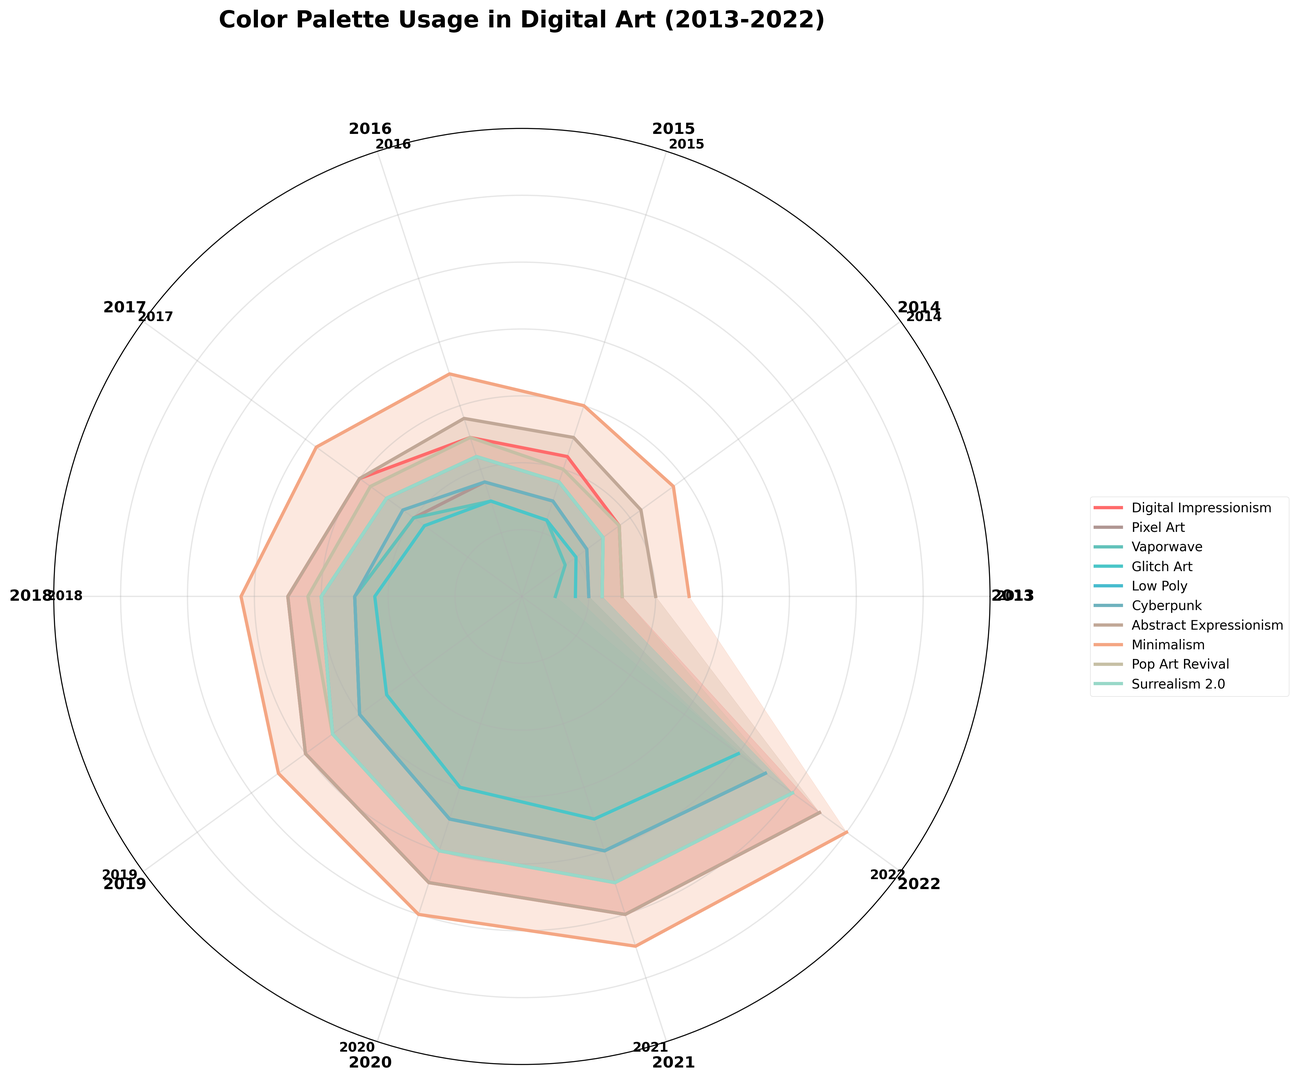Which artistic movement showed the most significant increase in color palette usage between 2018 and 2022? To find the movement with the most significant increase, we look at the difference between 2018 and 2022 for each movement. By observing the plotted values, Minimalism had an increase from 42 to 60, which is 18, the highest increase among the movements.
Answer: Minimalism In which year did Digital Impressionism surpass 40 in color palette usage? We look at the plotted values for Digital Impressionism and identify the year where it first reached or exceeded 40. The values surpass 40 in 2019 with a value of 40.
Answer: 2019 What is the median value of color palette usage for Abstract Expressionism across all years? There are 10 data points for Abstract Expressionism. To find the median, order values (20, 22, 25, 28, 30, 35, 40, 45, 50, 55) and the median would be the average of the 5th and 6th values: (30+35)/2 = 32.5
Answer: 32.5 Which two years showed the steepest slope in color palette usage for Cyberpunk? Observing the plot for Cyberpunk, we identify two years between which the increase is the steepest. The slope from 2017 (22) to 2018 (25) shows a steep increase compared to other years.
Answer: 2017 and 2018 How did the usage of color palettes in Pixel Art change from 2013 to 2020? To determine the change, subtract the usage in 2013 (10) from that in 2020 (35). The change is 35 - 10 = 25.
Answer: Increased by 25 Which artistic movement had the least variation in color palette usage over the decade? By observing the radii (lengths) and fluctuation in the plot, Digital Impressionism, starting at 15 and ending at 55 with the least noticeable fluctuations compared to movements like Minimalism, shows a more consistent increase.
Answer: Digital Impressionism In which year did Glitch Art and Pop Art Revival have the same color palette usage? Observing the plot data points, Glitch Art and Pop Art Revival are both at 15 in the year 2014.
Answer: 2014 Which artistic movement was consistently ahead in color palette usage from 2013 to 2022? Observing the plot consistently more prominent over other movements, Minimalism started higher and remained visibly ahead throughout the decade.
Answer: Minimalism 